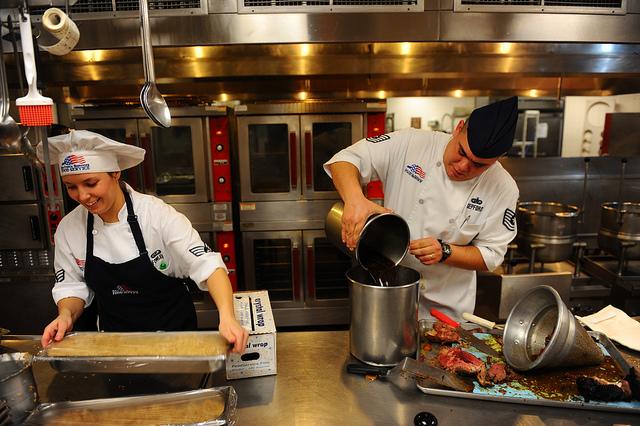Are the people cooking?
Keep it brief. Yes. Which person is in the black hat?
Short answer required. Man. Are they chefs?
Answer briefly. Yes. 